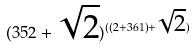Convert formula to latex. <formula><loc_0><loc_0><loc_500><loc_500>( 3 5 2 + \sqrt { 2 } ) ^ { ( ( 2 + 3 6 1 ) + \sqrt { 2 } ) }</formula> 